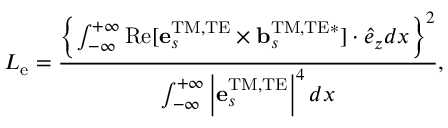<formula> <loc_0><loc_0><loc_500><loc_500>L _ { e } = \frac { \left \{ \int _ { - \infty } ^ { + \infty } R e [ { e } _ { s } ^ { T M , T E } \times { b } _ { s } ^ { T M , T E * } ] \cdot \hat { e } _ { z } d x \right \} ^ { 2 } } { \int _ { - \infty } ^ { + \infty } \left | { e } _ { s } ^ { T M , T E } \right | ^ { 4 } d x } ,</formula> 